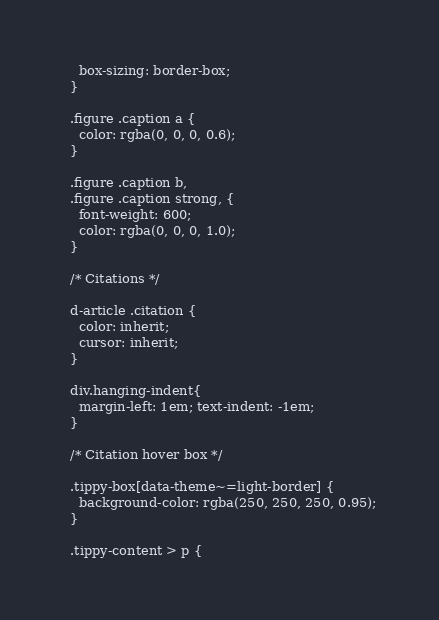Convert code to text. <code><loc_0><loc_0><loc_500><loc_500><_HTML_>    box-sizing: border-box;
  }
  
  .figure .caption a {
    color: rgba(0, 0, 0, 0.6);
  }
  
  .figure .caption b,
  .figure .caption strong, {
    font-weight: 600;
    color: rgba(0, 0, 0, 1.0);
  }
  
  /* Citations */
  
  d-article .citation {
    color: inherit;
    cursor: inherit;
  }
  
  div.hanging-indent{
    margin-left: 1em; text-indent: -1em;
  }
  
  /* Citation hover box */
  
  .tippy-box[data-theme~=light-border] {
    background-color: rgba(250, 250, 250, 0.95);
  }
  
  .tippy-content > p {</code> 